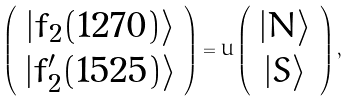<formula> <loc_0><loc_0><loc_500><loc_500>\left ( \begin{array} { c } | f _ { 2 } ( 1 2 7 0 ) \rangle \\ | f ^ { \prime } _ { 2 } ( 1 5 2 5 ) \rangle \end{array} \right ) = U \left ( \begin{array} { c } | N \rangle \\ | S \rangle \end{array} \right ) ,</formula> 